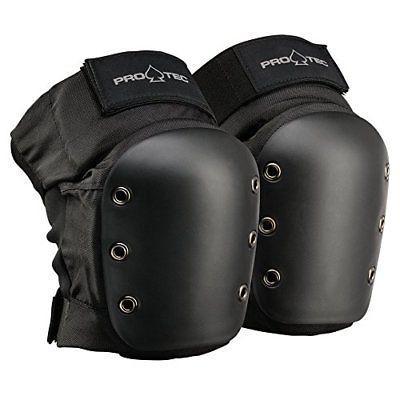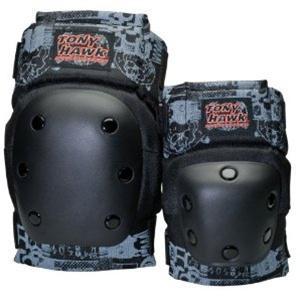The first image is the image on the left, the second image is the image on the right. Examine the images to the left and right. Is the description "Each set of images contains more than four pads." accurate? Answer yes or no. No. 